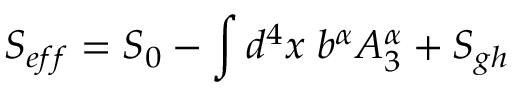<formula> <loc_0><loc_0><loc_500><loc_500>S _ { e f f } = S _ { 0 } - \int d ^ { 4 } x \, b ^ { \alpha } A _ { 3 } ^ { \alpha } + S _ { g h }</formula> 